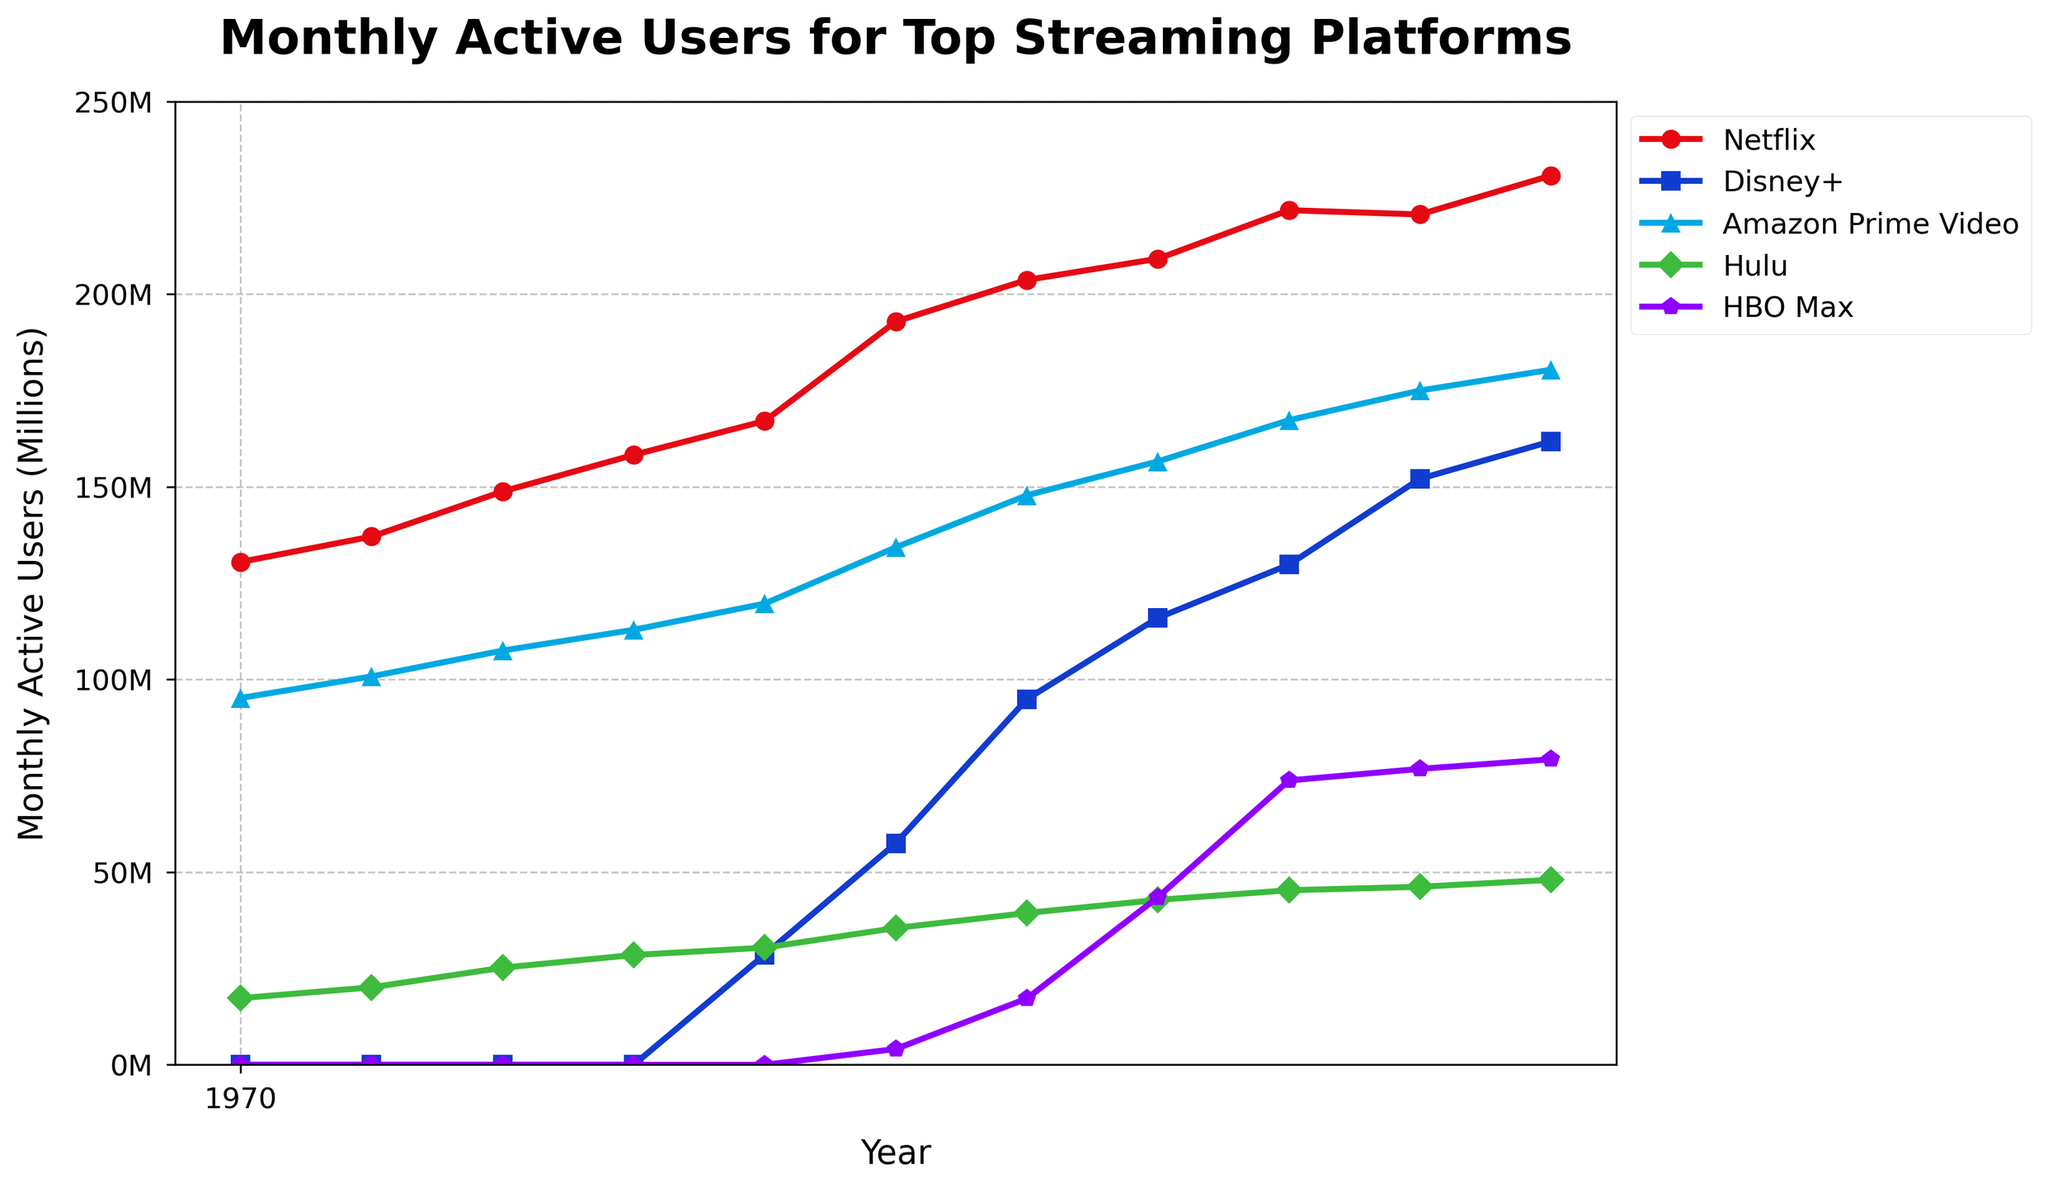What's the user base difference between Netflix and Disney+ in July 2022? To find the difference, read the user numbers for Netflix and Disney+ in July 2022 and subtract Disney+'s 152.1 million from Netflix's 220.7 million: 220.7 - 152.1 = 68.6 million.
Answer: 68.6 million Which streaming platform had the fastest growth between January 2020 and January 2023? To determine the fastest growth, calculate the difference in user base for each platform between January 2020 and January 2023, and then compare the differences: Netflix (230.8 - 167.1 = 63.7 million), Disney+ (161.8 - 28.6 = 133.2 million), Amazon Prime Video (180.4 - 119.7 = 60.7 million), Hulu (48.0 - 30.4 = 17.6 million), HBO Max (79.3 - 0 = 79.3 million). Disney+ shows the highest increase: 133.2 million.
Answer: Disney+ As of January 2023, which platform has the lowest number of monthly active users? To find the platform with the lowest active users, check the user base for each platform in January 2023: Netflix (230.8), Disney+ (161.8), Amazon Prime Video (180.4), Hulu (48), and HBO Max (79.3). The smallest is Hulu, with 48 million users.
Answer: Hulu What is the total number of users across all platforms in January 2021? Sum the user bases for all platforms in January 2021: Netflix (203.7) + Disney+ (94.9) + Amazon Prime Video (147.8) + Hulu (39.4) + HBO Max (17.2) = 503 million users in total.
Answer: 503 million How do the users of Amazon Prime Video in January 2020 compare with those in July 2020? To compare the users, look at the number of users in January 2020 (119.7 million) and July 2020 (134.3 million). Amazon Prime Video's user count increased by 134.3 - 119.7 = 14.6 million.
Answer: Increased by 14.6 million Which streaming service showed the most significant user increase between July 2021 and January 2022? To find the most significant increase, subtract the July 2021 users from the January 2022 users for each platform: Netflix (221.8 - 209.2 = 12.6 million), Disney+ (129.8 - 116 = 13.8 million), Amazon Prime Video (167.3 - 156.6 = 10.7 million), Hulu (45.3 - 42.8 = 2.5 million), HBO Max (73.8 - 43.5 = 30.3 million). HBO Max had the most significant increase of 30.3 million.
Answer: HBO Max What has been the trend of HBO Max's users since its launch? To understand the trend, look at the data points for HBO Max starting from July 2020: 4.1 million (July 2020), 17.2 million (January 2021), 43.5 million (July 2021), 73.8 million (January 2022), 76.8 million (July 2022), 79.3 million (January 2023). The number of users has been consistently increasing.
Answer: Increasing What's the average number of monthly active users for Hulu over the entire period? To find the average, sum the user numbers for Hulu across all dates and divide by the number of data points: (17.3 + 20.1 + 25.2 + 28.5 + 30.4 + 35.5 + 39.4 + 42.8 + 45.3 + 46.2 + 48.0) / 11 = 33.6 million.
Answer: 33.6 million 